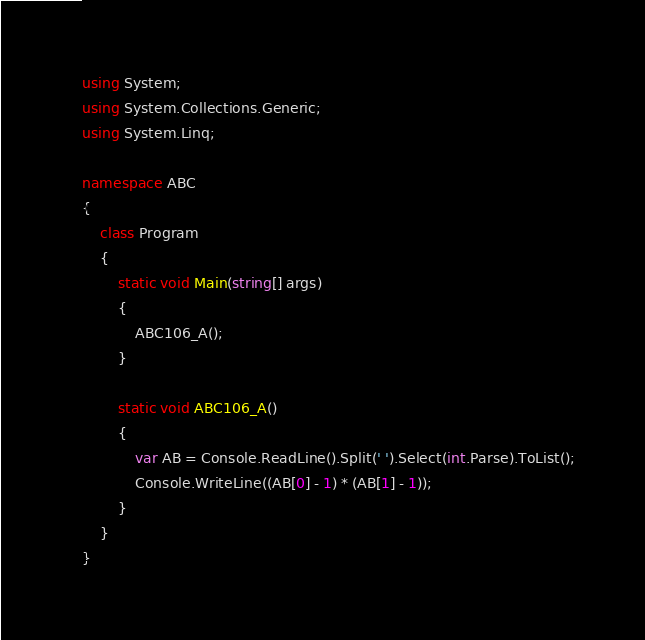Convert code to text. <code><loc_0><loc_0><loc_500><loc_500><_C#_>using System;
using System.Collections.Generic;
using System.Linq;

namespace ABC
{
    class Program
    {
        static void Main(string[] args)
        {
            ABC106_A();
        }

        static void ABC106_A()
        {
            var AB = Console.ReadLine().Split(' ').Select(int.Parse).ToList();
            Console.WriteLine((AB[0] - 1) * (AB[1] - 1));
        }
    }
}</code> 